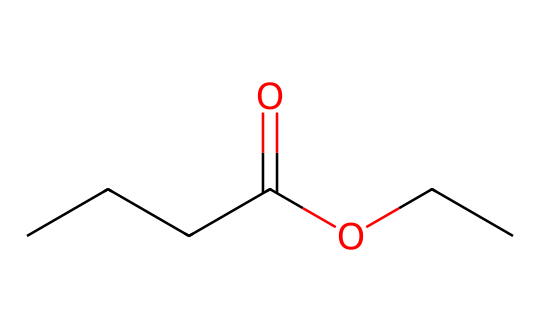What is the main functional group present in ethyl butyrate? The functional group can be identified from the SMILES representation, specifically the part "CCCC(=O)OCC," where the "=O" indicates a carbonyl group (C=O) and "O" indicates an ester functional group. Thus, the molecule contains an ester functional group.
Answer: ester How many carbon atoms are in ethyl butyrate? By analyzing the SMILES representation "CCCC(=O)OCC," we count four carbon atoms in the butyrate portion (CCCC) and two in the ethyl group (CC), resulting in a total of six carbon atoms.
Answer: 6 What type of fragrance is ethyl butyrate associated with? Ethyl butyrate is typically associated with fruity scents, particularly resembling the aroma of bananas, which is recognized in various food formulations and artificial flavors.
Answer: fruity What is the molecular formula of ethyl butyrate? From the structure given in the SMILES, we deduce the elements and their counts: 6 carbons, 12 hydrogens, and 2 oxygens, which gives us the molecular formula C6H12O2.
Answer: C6H12O2 How does the structure of ethyl butyrate impact its volatility compared to butanoic acid? Ethyl butyrate has a lower boiling point due to its ester form leading to weaker intermolecular forces compared to the hydrogen bonding in butanoic acid, which translates into higher volatility and a more pronounced aroma.
Answer: higher volatility 